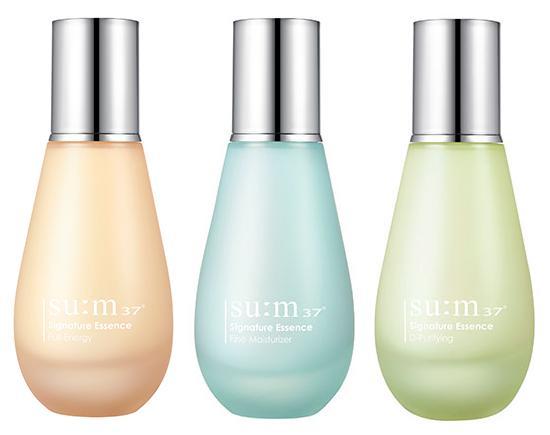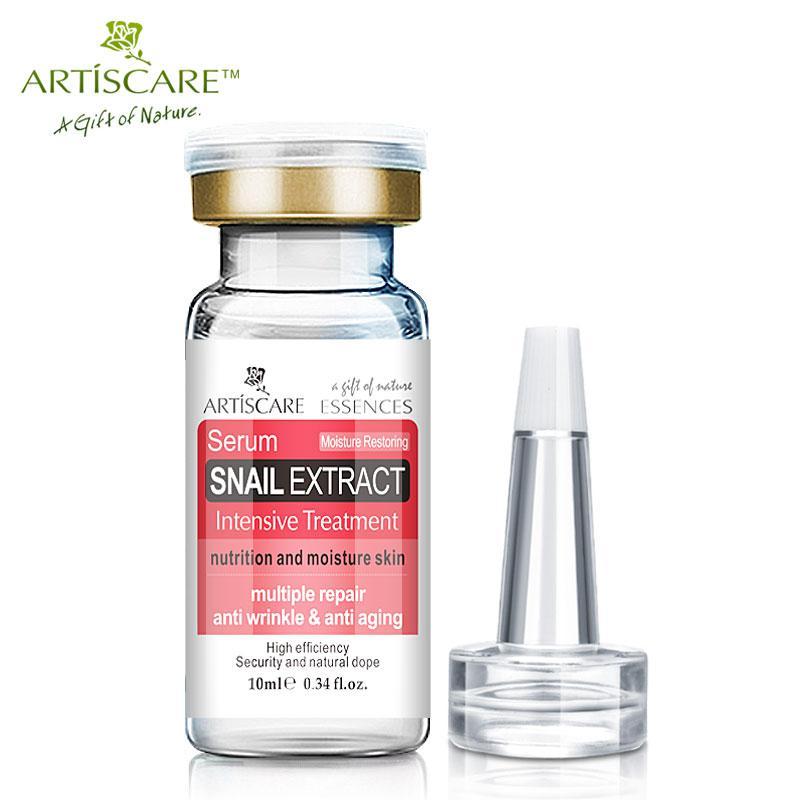The first image is the image on the left, the second image is the image on the right. Examine the images to the left and right. Is the description "There are a total of two beauty product containers." accurate? Answer yes or no. No. The first image is the image on the left, the second image is the image on the right. Analyze the images presented: Is the assertion "One image shows a single bottle with its applicator top next to it." valid? Answer yes or no. Yes. 